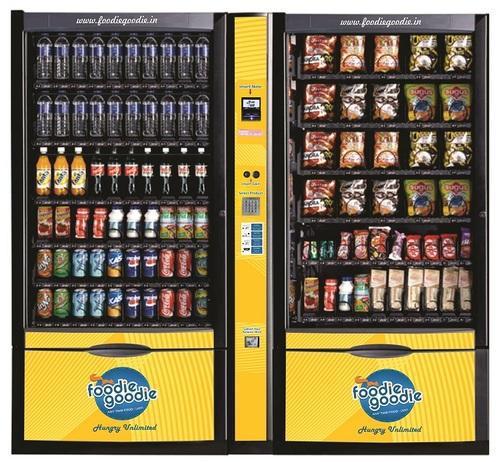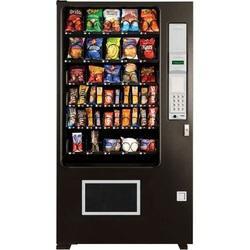The first image is the image on the left, the second image is the image on the right. Examine the images to the left and right. Is the description "In one image, a vending machine unit has a central payment panel with equal sized vending machines on each side with six shelves each." accurate? Answer yes or no. Yes. The first image is the image on the left, the second image is the image on the right. Assess this claim about the two images: "There are more machines in the image on the left than in the image on the right.". Correct or not? Answer yes or no. Yes. 